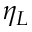<formula> <loc_0><loc_0><loc_500><loc_500>\eta _ { L }</formula> 